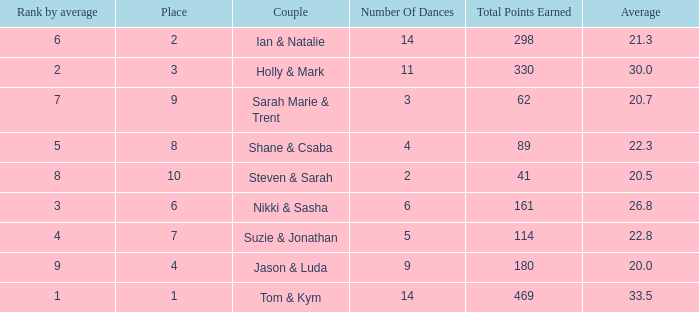What was the name of the couple if the number of dances is 6? Nikki & Sasha. 